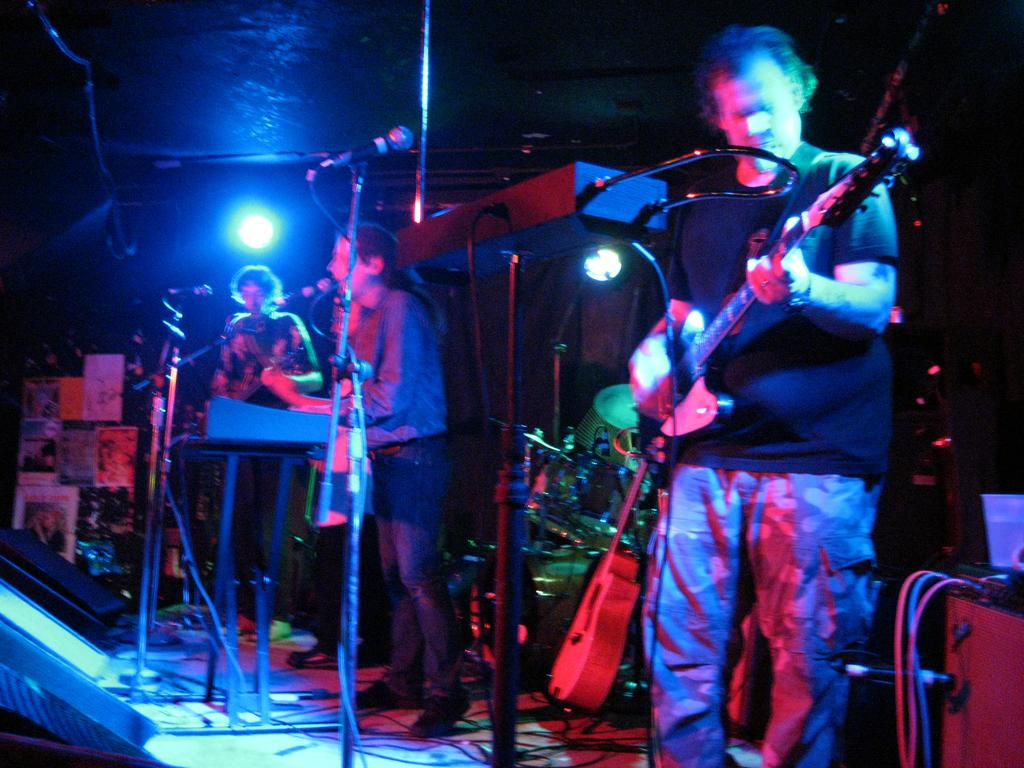What is happening in the image involving a group of people? In the image, a group of people are playing musical instruments. Is there any other activity being performed by someone in the group? Yes, one person is singing in front of a microphone. Are the people wearing masks while playing their instruments? There is no mention of masks in the image, so we cannot determine if they are wearing them or not. 